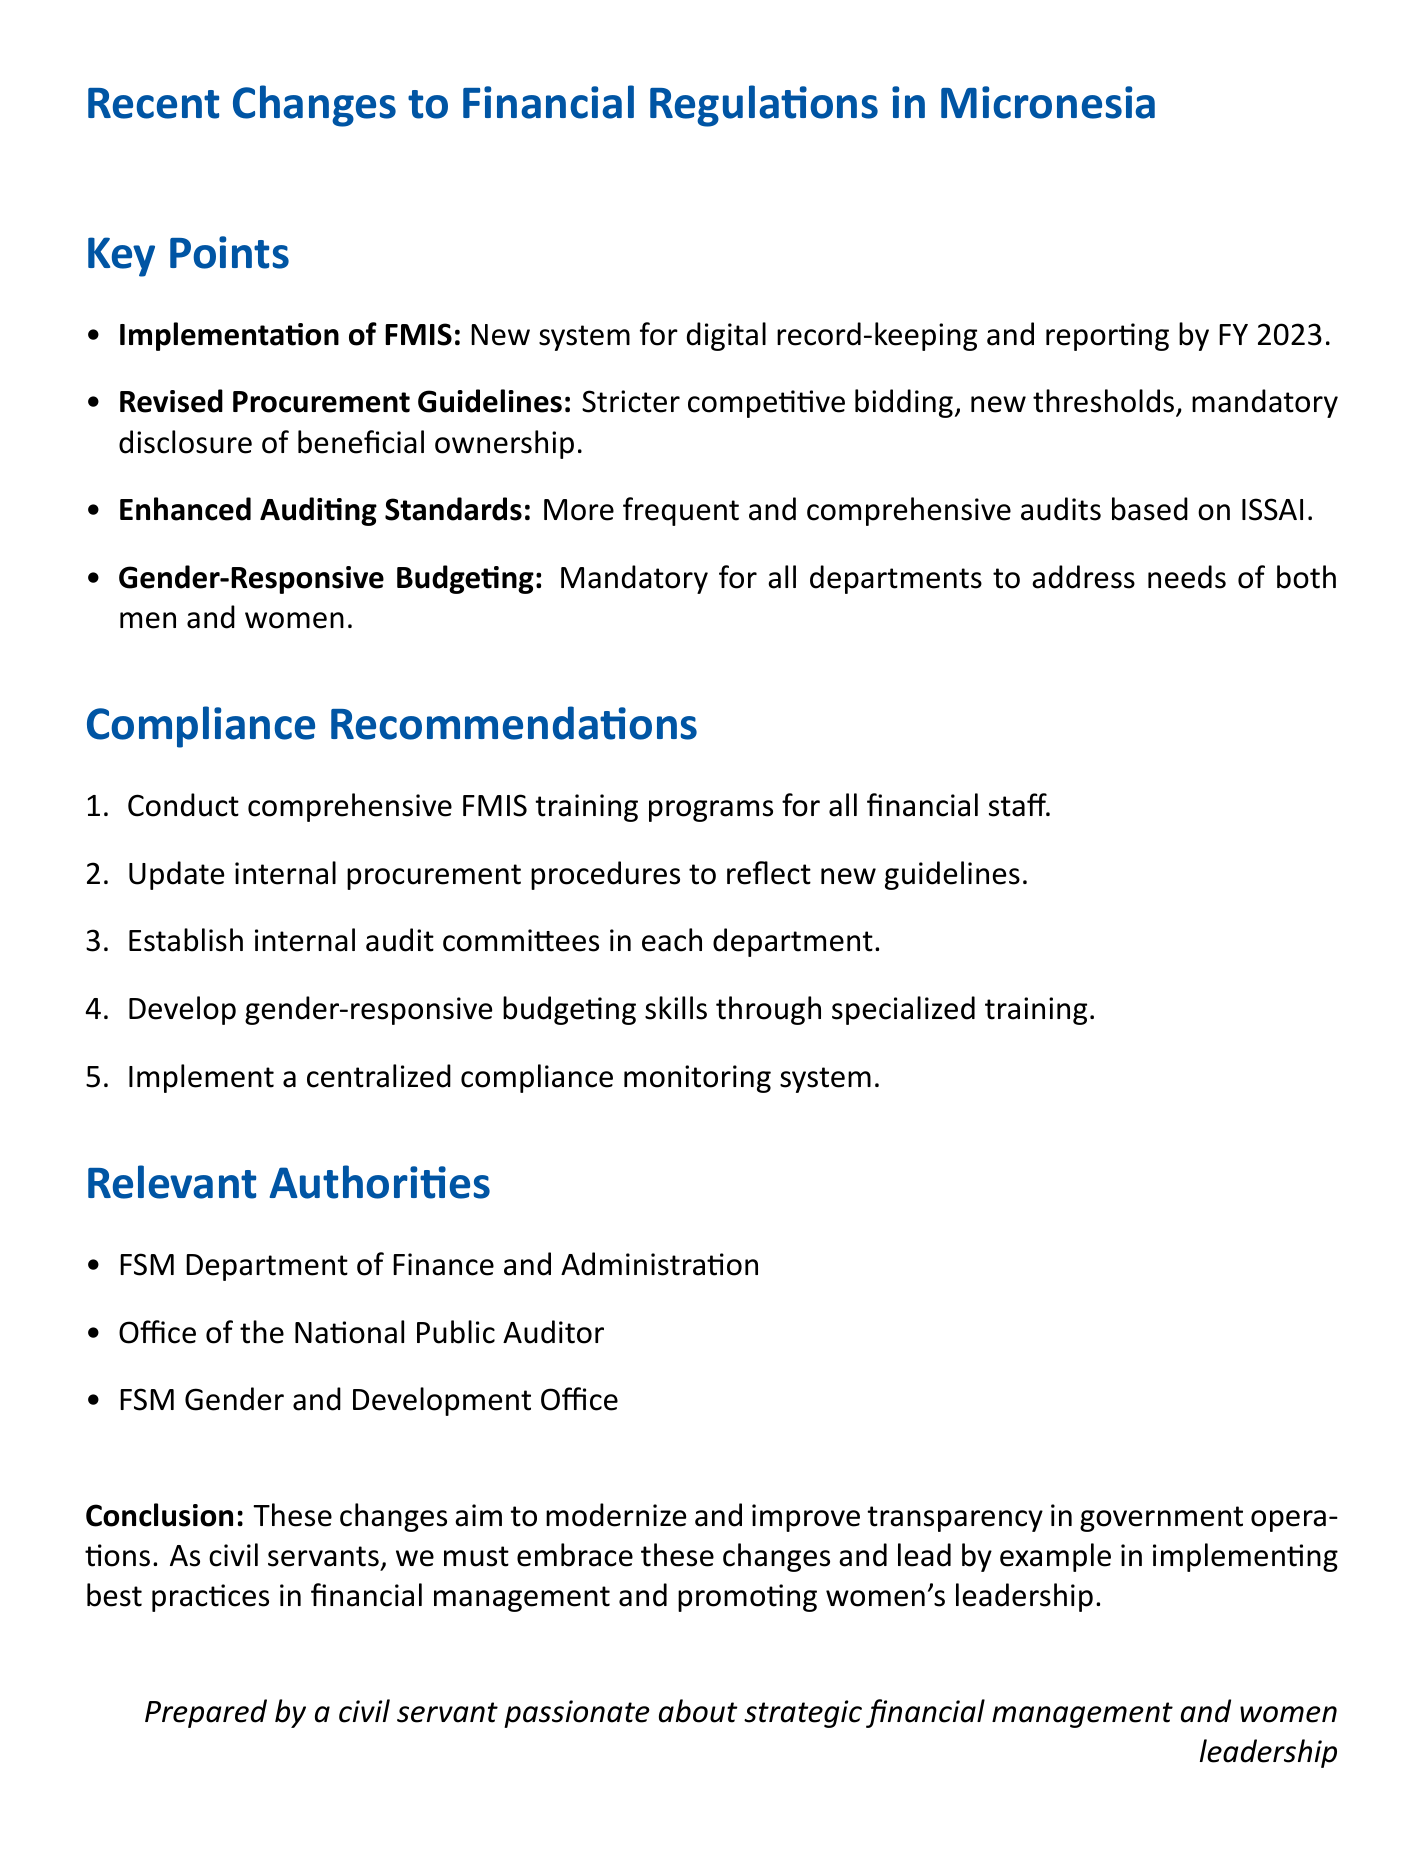what is the new system adopted for government financial operations? The document states that the FSM has adopted a new Financial Management Information System (FMIS) to enhance transparency and efficiency in government financial operations.
Answer: Financial Management Information System (FMIS) by when must all government departments transition to digital record-keeping? The document indicates that all government departments are required to transition to digital record-keeping by the end of fiscal year 2023.
Answer: end of fiscal year 2023 what initiative requires government departments to incorporate gender-responsive budgeting? The document introduces a Gender-Responsive Budgeting Initiative, which mandates that government departments include gender-responsive budgeting in their annual financial plans.
Answer: Gender-Responsive Budgeting Initiative who is responsible for conducting audits in accordance with new auditing standards? The document specifies that the Office of the National Public Auditor is responsible for conducting audits and ensuring compliance with the new auditing standards.
Answer: Office of the National Public Auditor what is the primary authority overseeing the implementation of the new financial regulations? The document mentions that the FSM Department of Finance and Administration is the primary authority responsible for overseeing the implementation of new financial regulations.
Answer: FSM Department of Finance and Administration what is one potential challenge faced in implementing the FMIS? The document highlights that limited digital infrastructure in some regions of Micronesia may hinder the full implementation of the FMIS.
Answer: Limited digital infrastructure what recommendation is suggested for financial staff regarding the FMIS? The document recommends conducting comprehensive training programs for all financial staff on the new FMIS to ensure compliance.
Answer: Conduct FMIS Training Programs why is it important to revise departmental procurement manuals? The document states that updating internal procurement procedures is vital to reflect the new guidelines and emphasize the importance of competitive bidding and transparency.
Answer: Reflect new guidelines how does the memo suggest promoting women's leadership in decision-making processes? The memo calls for civil servants to embrace changes and lead by example in promoting women's leadership in decision-making processes.
Answer: Promote women's leadership 